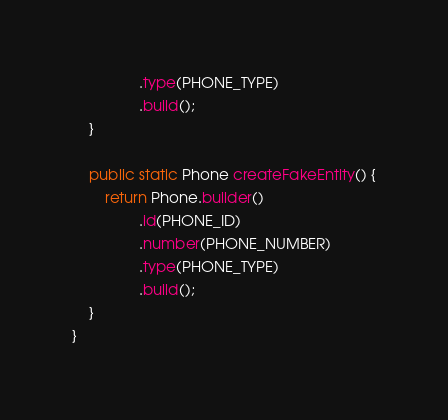Convert code to text. <code><loc_0><loc_0><loc_500><loc_500><_Java_>                .type(PHONE_TYPE)
                .build();
    }

    public static Phone createFakeEntity() {
        return Phone.builder()
                .id(PHONE_ID)
                .number(PHONE_NUMBER)
                .type(PHONE_TYPE)
                .build();
    }
}
</code> 